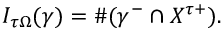<formula> <loc_0><loc_0><loc_500><loc_500>I _ { \tau \Omega } ( \gamma ) = \# ( \gamma ^ { - } \cap X ^ { \tau + } ) .</formula> 